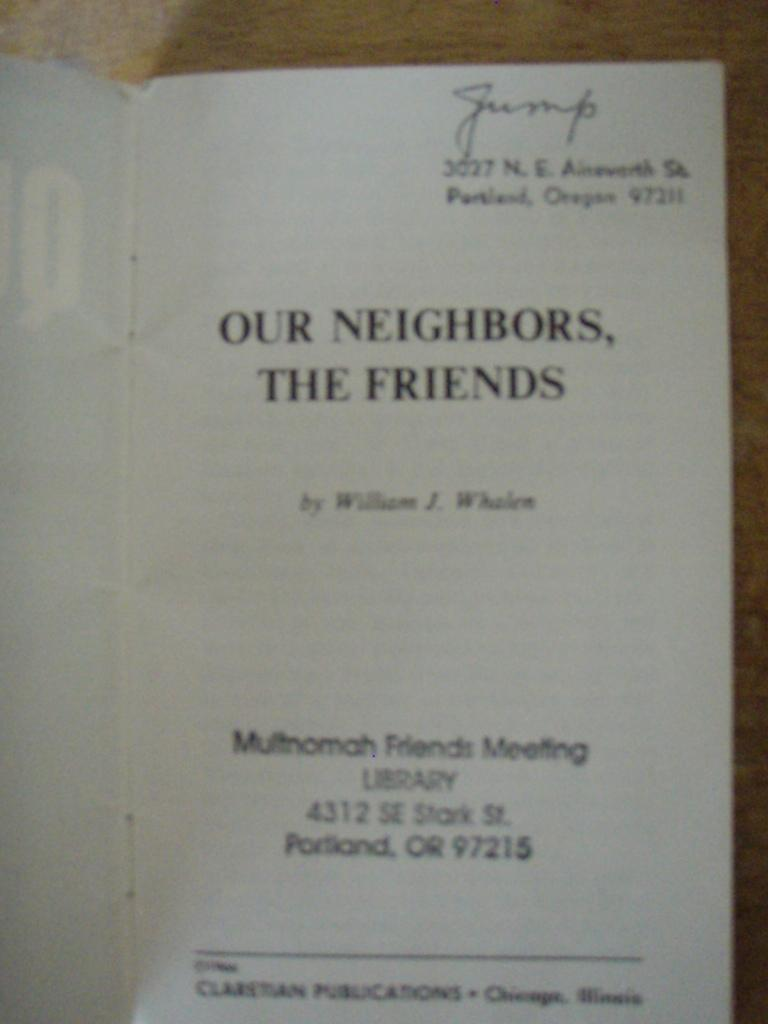<image>
Offer a succinct explanation of the picture presented. The book "Our Neighbors, The Friends" is open to the title page stamped with a library's address. 